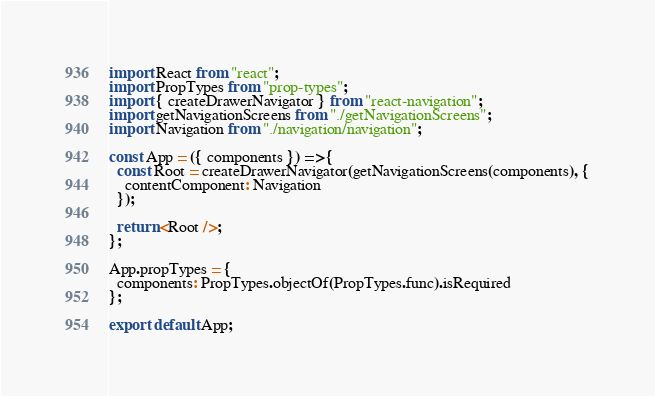Convert code to text. <code><loc_0><loc_0><loc_500><loc_500><_JavaScript_>import React from "react";
import PropTypes from "prop-types";
import { createDrawerNavigator } from "react-navigation";
import getNavigationScreens from "./getNavigationScreens";
import Navigation from "./navigation/navigation";

const App = ({ components }) => {
  const Root = createDrawerNavigator(getNavigationScreens(components), {
    contentComponent: Navigation
  });

  return <Root />;
};

App.propTypes = {
  components: PropTypes.objectOf(PropTypes.func).isRequired
};

export default App;
</code> 